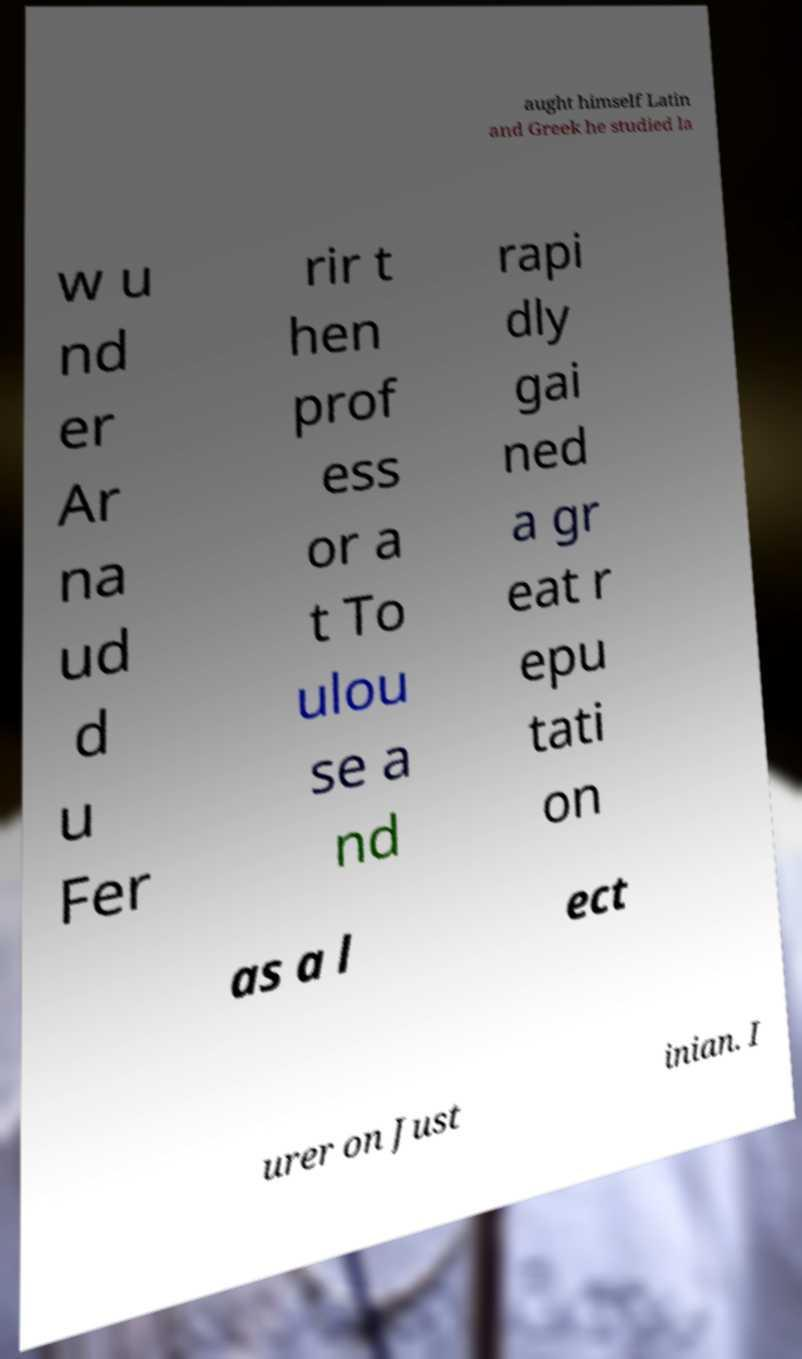Can you read and provide the text displayed in the image?This photo seems to have some interesting text. Can you extract and type it out for me? aught himself Latin and Greek he studied la w u nd er Ar na ud d u Fer rir t hen prof ess or a t To ulou se a nd rapi dly gai ned a gr eat r epu tati on as a l ect urer on Just inian. I 